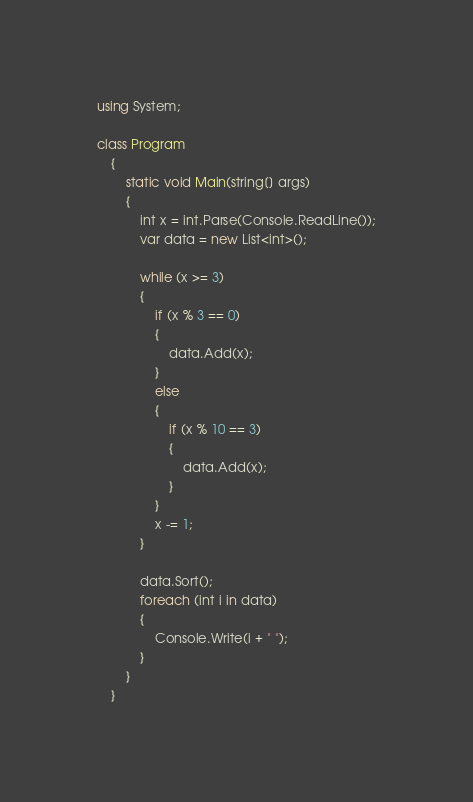Convert code to text. <code><loc_0><loc_0><loc_500><loc_500><_C#_>using System;

class Program
    {
        static void Main(string[] args)
        {
            int x = int.Parse(Console.ReadLine());
            var data = new List<int>();

            while (x >= 3)
            {
                if (x % 3 == 0)
                {
                    data.Add(x);
                }
                else
                {
                    if (x % 10 == 3)
                    {
                        data.Add(x);
                    }
                }
                x -= 1;
            }

            data.Sort();
            foreach (int i in data)
            {
                Console.Write(i + " ");
            }
        }
    }</code> 